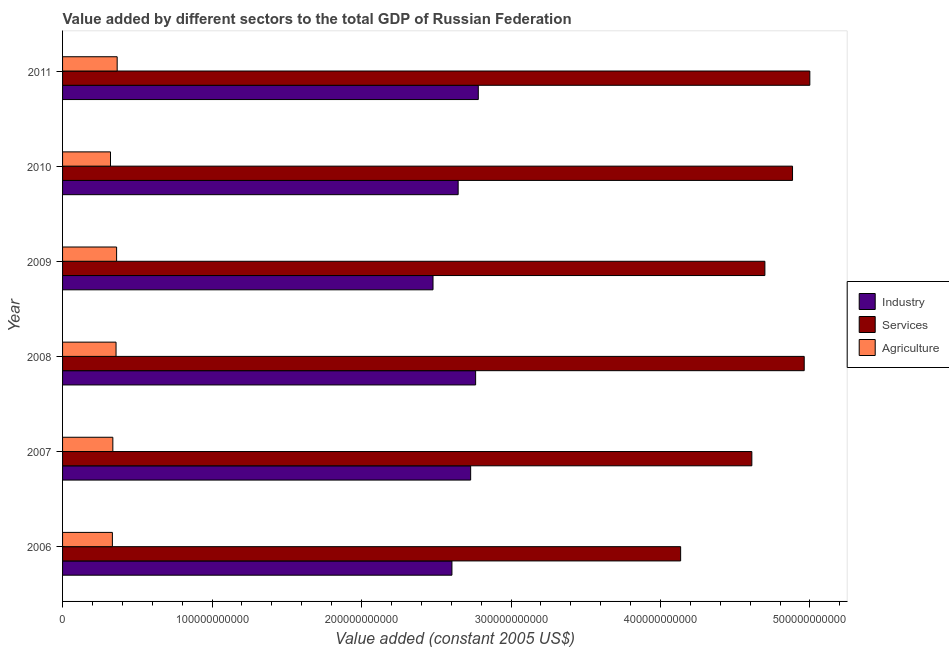How many groups of bars are there?
Provide a succinct answer. 6. Are the number of bars per tick equal to the number of legend labels?
Ensure brevity in your answer.  Yes. Are the number of bars on each tick of the Y-axis equal?
Ensure brevity in your answer.  Yes. How many bars are there on the 4th tick from the top?
Make the answer very short. 3. How many bars are there on the 4th tick from the bottom?
Offer a terse response. 3. What is the value added by services in 2007?
Make the answer very short. 4.61e+11. Across all years, what is the maximum value added by services?
Ensure brevity in your answer.  5.00e+11. Across all years, what is the minimum value added by services?
Your answer should be compact. 4.13e+11. What is the total value added by industrial sector in the graph?
Provide a succinct answer. 1.60e+12. What is the difference between the value added by agricultural sector in 2006 and that in 2007?
Give a very brief answer. -3.06e+08. What is the difference between the value added by agricultural sector in 2010 and the value added by services in 2011?
Provide a succinct answer. -4.68e+11. What is the average value added by services per year?
Ensure brevity in your answer.  4.71e+11. In the year 2010, what is the difference between the value added by industrial sector and value added by agricultural sector?
Your answer should be compact. 2.33e+11. What is the ratio of the value added by services in 2007 to that in 2011?
Provide a succinct answer. 0.92. Is the value added by agricultural sector in 2006 less than that in 2011?
Offer a terse response. Yes. What is the difference between the highest and the second highest value added by agricultural sector?
Your answer should be very brief. 3.86e+08. What is the difference between the highest and the lowest value added by industrial sector?
Offer a terse response. 3.03e+1. In how many years, is the value added by services greater than the average value added by services taken over all years?
Keep it short and to the point. 3. What does the 2nd bar from the top in 2007 represents?
Your response must be concise. Services. What does the 2nd bar from the bottom in 2011 represents?
Offer a terse response. Services. How many bars are there?
Your response must be concise. 18. Are all the bars in the graph horizontal?
Offer a terse response. Yes. How many years are there in the graph?
Offer a terse response. 6. What is the difference between two consecutive major ticks on the X-axis?
Offer a very short reply. 1.00e+11. Does the graph contain grids?
Your response must be concise. No. How many legend labels are there?
Give a very brief answer. 3. How are the legend labels stacked?
Your answer should be compact. Vertical. What is the title of the graph?
Offer a terse response. Value added by different sectors to the total GDP of Russian Federation. Does "Communicable diseases" appear as one of the legend labels in the graph?
Give a very brief answer. No. What is the label or title of the X-axis?
Offer a very short reply. Value added (constant 2005 US$). What is the Value added (constant 2005 US$) in Industry in 2006?
Ensure brevity in your answer.  2.60e+11. What is the Value added (constant 2005 US$) of Services in 2006?
Ensure brevity in your answer.  4.13e+11. What is the Value added (constant 2005 US$) of Agriculture in 2006?
Your answer should be compact. 3.33e+1. What is the Value added (constant 2005 US$) in Industry in 2007?
Your response must be concise. 2.73e+11. What is the Value added (constant 2005 US$) of Services in 2007?
Offer a very short reply. 4.61e+11. What is the Value added (constant 2005 US$) of Agriculture in 2007?
Offer a very short reply. 3.36e+1. What is the Value added (constant 2005 US$) in Industry in 2008?
Ensure brevity in your answer.  2.76e+11. What is the Value added (constant 2005 US$) in Services in 2008?
Your response must be concise. 4.96e+11. What is the Value added (constant 2005 US$) in Agriculture in 2008?
Offer a terse response. 3.58e+1. What is the Value added (constant 2005 US$) of Industry in 2009?
Offer a terse response. 2.48e+11. What is the Value added (constant 2005 US$) of Services in 2009?
Keep it short and to the point. 4.70e+11. What is the Value added (constant 2005 US$) in Agriculture in 2009?
Provide a succinct answer. 3.61e+1. What is the Value added (constant 2005 US$) of Industry in 2010?
Make the answer very short. 2.65e+11. What is the Value added (constant 2005 US$) of Services in 2010?
Your answer should be very brief. 4.88e+11. What is the Value added (constant 2005 US$) in Agriculture in 2010?
Provide a short and direct response. 3.21e+1. What is the Value added (constant 2005 US$) of Industry in 2011?
Your answer should be very brief. 2.78e+11. What is the Value added (constant 2005 US$) of Services in 2011?
Your answer should be very brief. 5.00e+11. What is the Value added (constant 2005 US$) of Agriculture in 2011?
Ensure brevity in your answer.  3.65e+1. Across all years, what is the maximum Value added (constant 2005 US$) of Industry?
Give a very brief answer. 2.78e+11. Across all years, what is the maximum Value added (constant 2005 US$) in Services?
Ensure brevity in your answer.  5.00e+11. Across all years, what is the maximum Value added (constant 2005 US$) in Agriculture?
Keep it short and to the point. 3.65e+1. Across all years, what is the minimum Value added (constant 2005 US$) of Industry?
Your answer should be very brief. 2.48e+11. Across all years, what is the minimum Value added (constant 2005 US$) of Services?
Provide a succinct answer. 4.13e+11. Across all years, what is the minimum Value added (constant 2005 US$) of Agriculture?
Offer a very short reply. 3.21e+1. What is the total Value added (constant 2005 US$) in Industry in the graph?
Make the answer very short. 1.60e+12. What is the total Value added (constant 2005 US$) in Services in the graph?
Keep it short and to the point. 2.83e+12. What is the total Value added (constant 2005 US$) of Agriculture in the graph?
Ensure brevity in your answer.  2.07e+11. What is the difference between the Value added (constant 2005 US$) in Industry in 2006 and that in 2007?
Ensure brevity in your answer.  -1.25e+1. What is the difference between the Value added (constant 2005 US$) in Services in 2006 and that in 2007?
Offer a terse response. -4.76e+1. What is the difference between the Value added (constant 2005 US$) in Agriculture in 2006 and that in 2007?
Your response must be concise. -3.06e+08. What is the difference between the Value added (constant 2005 US$) of Industry in 2006 and that in 2008?
Provide a succinct answer. -1.58e+1. What is the difference between the Value added (constant 2005 US$) of Services in 2006 and that in 2008?
Your answer should be compact. -8.27e+1. What is the difference between the Value added (constant 2005 US$) of Agriculture in 2006 and that in 2008?
Your response must be concise. -2.44e+09. What is the difference between the Value added (constant 2005 US$) of Industry in 2006 and that in 2009?
Your answer should be very brief. 1.27e+1. What is the difference between the Value added (constant 2005 US$) in Services in 2006 and that in 2009?
Offer a very short reply. -5.64e+1. What is the difference between the Value added (constant 2005 US$) of Agriculture in 2006 and that in 2009?
Offer a terse response. -2.82e+09. What is the difference between the Value added (constant 2005 US$) in Industry in 2006 and that in 2010?
Offer a very short reply. -4.16e+09. What is the difference between the Value added (constant 2005 US$) of Services in 2006 and that in 2010?
Keep it short and to the point. -7.49e+1. What is the difference between the Value added (constant 2005 US$) of Agriculture in 2006 and that in 2010?
Ensure brevity in your answer.  1.27e+09. What is the difference between the Value added (constant 2005 US$) of Industry in 2006 and that in 2011?
Give a very brief answer. -1.76e+1. What is the difference between the Value added (constant 2005 US$) of Services in 2006 and that in 2011?
Your answer should be very brief. -8.64e+1. What is the difference between the Value added (constant 2005 US$) of Agriculture in 2006 and that in 2011?
Offer a very short reply. -3.21e+09. What is the difference between the Value added (constant 2005 US$) in Industry in 2007 and that in 2008?
Keep it short and to the point. -3.32e+09. What is the difference between the Value added (constant 2005 US$) in Services in 2007 and that in 2008?
Offer a very short reply. -3.50e+1. What is the difference between the Value added (constant 2005 US$) of Agriculture in 2007 and that in 2008?
Offer a very short reply. -2.14e+09. What is the difference between the Value added (constant 2005 US$) of Industry in 2007 and that in 2009?
Your answer should be very brief. 2.52e+1. What is the difference between the Value added (constant 2005 US$) of Services in 2007 and that in 2009?
Your answer should be compact. -8.73e+09. What is the difference between the Value added (constant 2005 US$) of Agriculture in 2007 and that in 2009?
Keep it short and to the point. -2.51e+09. What is the difference between the Value added (constant 2005 US$) of Industry in 2007 and that in 2010?
Your response must be concise. 8.37e+09. What is the difference between the Value added (constant 2005 US$) of Services in 2007 and that in 2010?
Keep it short and to the point. -2.72e+1. What is the difference between the Value added (constant 2005 US$) of Agriculture in 2007 and that in 2010?
Your answer should be compact. 1.57e+09. What is the difference between the Value added (constant 2005 US$) in Industry in 2007 and that in 2011?
Your response must be concise. -5.12e+09. What is the difference between the Value added (constant 2005 US$) in Services in 2007 and that in 2011?
Your answer should be very brief. -3.88e+1. What is the difference between the Value added (constant 2005 US$) of Agriculture in 2007 and that in 2011?
Ensure brevity in your answer.  -2.90e+09. What is the difference between the Value added (constant 2005 US$) of Industry in 2008 and that in 2009?
Make the answer very short. 2.85e+1. What is the difference between the Value added (constant 2005 US$) of Services in 2008 and that in 2009?
Offer a very short reply. 2.63e+1. What is the difference between the Value added (constant 2005 US$) of Agriculture in 2008 and that in 2009?
Provide a succinct answer. -3.77e+08. What is the difference between the Value added (constant 2005 US$) in Industry in 2008 and that in 2010?
Keep it short and to the point. 1.17e+1. What is the difference between the Value added (constant 2005 US$) in Services in 2008 and that in 2010?
Provide a succinct answer. 7.82e+09. What is the difference between the Value added (constant 2005 US$) of Agriculture in 2008 and that in 2010?
Ensure brevity in your answer.  3.71e+09. What is the difference between the Value added (constant 2005 US$) of Industry in 2008 and that in 2011?
Offer a terse response. -1.80e+09. What is the difference between the Value added (constant 2005 US$) of Services in 2008 and that in 2011?
Your answer should be very brief. -3.76e+09. What is the difference between the Value added (constant 2005 US$) in Agriculture in 2008 and that in 2011?
Your answer should be compact. -7.63e+08. What is the difference between the Value added (constant 2005 US$) of Industry in 2009 and that in 2010?
Ensure brevity in your answer.  -1.68e+1. What is the difference between the Value added (constant 2005 US$) in Services in 2009 and that in 2010?
Ensure brevity in your answer.  -1.85e+1. What is the difference between the Value added (constant 2005 US$) of Agriculture in 2009 and that in 2010?
Give a very brief answer. 4.09e+09. What is the difference between the Value added (constant 2005 US$) in Industry in 2009 and that in 2011?
Your response must be concise. -3.03e+1. What is the difference between the Value added (constant 2005 US$) of Services in 2009 and that in 2011?
Provide a short and direct response. -3.01e+1. What is the difference between the Value added (constant 2005 US$) in Agriculture in 2009 and that in 2011?
Make the answer very short. -3.86e+08. What is the difference between the Value added (constant 2005 US$) of Industry in 2010 and that in 2011?
Ensure brevity in your answer.  -1.35e+1. What is the difference between the Value added (constant 2005 US$) of Services in 2010 and that in 2011?
Ensure brevity in your answer.  -1.16e+1. What is the difference between the Value added (constant 2005 US$) of Agriculture in 2010 and that in 2011?
Provide a succinct answer. -4.47e+09. What is the difference between the Value added (constant 2005 US$) of Industry in 2006 and the Value added (constant 2005 US$) of Services in 2007?
Make the answer very short. -2.01e+11. What is the difference between the Value added (constant 2005 US$) of Industry in 2006 and the Value added (constant 2005 US$) of Agriculture in 2007?
Offer a terse response. 2.27e+11. What is the difference between the Value added (constant 2005 US$) of Services in 2006 and the Value added (constant 2005 US$) of Agriculture in 2007?
Your response must be concise. 3.80e+11. What is the difference between the Value added (constant 2005 US$) of Industry in 2006 and the Value added (constant 2005 US$) of Services in 2008?
Offer a very short reply. -2.36e+11. What is the difference between the Value added (constant 2005 US$) of Industry in 2006 and the Value added (constant 2005 US$) of Agriculture in 2008?
Your answer should be very brief. 2.25e+11. What is the difference between the Value added (constant 2005 US$) of Services in 2006 and the Value added (constant 2005 US$) of Agriculture in 2008?
Your answer should be very brief. 3.78e+11. What is the difference between the Value added (constant 2005 US$) in Industry in 2006 and the Value added (constant 2005 US$) in Services in 2009?
Your response must be concise. -2.09e+11. What is the difference between the Value added (constant 2005 US$) in Industry in 2006 and the Value added (constant 2005 US$) in Agriculture in 2009?
Provide a succinct answer. 2.24e+11. What is the difference between the Value added (constant 2005 US$) in Services in 2006 and the Value added (constant 2005 US$) in Agriculture in 2009?
Offer a terse response. 3.77e+11. What is the difference between the Value added (constant 2005 US$) of Industry in 2006 and the Value added (constant 2005 US$) of Services in 2010?
Provide a short and direct response. -2.28e+11. What is the difference between the Value added (constant 2005 US$) in Industry in 2006 and the Value added (constant 2005 US$) in Agriculture in 2010?
Your answer should be compact. 2.28e+11. What is the difference between the Value added (constant 2005 US$) of Services in 2006 and the Value added (constant 2005 US$) of Agriculture in 2010?
Your answer should be compact. 3.81e+11. What is the difference between the Value added (constant 2005 US$) of Industry in 2006 and the Value added (constant 2005 US$) of Services in 2011?
Ensure brevity in your answer.  -2.39e+11. What is the difference between the Value added (constant 2005 US$) of Industry in 2006 and the Value added (constant 2005 US$) of Agriculture in 2011?
Offer a very short reply. 2.24e+11. What is the difference between the Value added (constant 2005 US$) in Services in 2006 and the Value added (constant 2005 US$) in Agriculture in 2011?
Your answer should be compact. 3.77e+11. What is the difference between the Value added (constant 2005 US$) in Industry in 2007 and the Value added (constant 2005 US$) in Services in 2008?
Keep it short and to the point. -2.23e+11. What is the difference between the Value added (constant 2005 US$) in Industry in 2007 and the Value added (constant 2005 US$) in Agriculture in 2008?
Make the answer very short. 2.37e+11. What is the difference between the Value added (constant 2005 US$) of Services in 2007 and the Value added (constant 2005 US$) of Agriculture in 2008?
Your answer should be very brief. 4.25e+11. What is the difference between the Value added (constant 2005 US$) in Industry in 2007 and the Value added (constant 2005 US$) in Services in 2009?
Provide a succinct answer. -1.97e+11. What is the difference between the Value added (constant 2005 US$) in Industry in 2007 and the Value added (constant 2005 US$) in Agriculture in 2009?
Provide a succinct answer. 2.37e+11. What is the difference between the Value added (constant 2005 US$) of Services in 2007 and the Value added (constant 2005 US$) of Agriculture in 2009?
Offer a very short reply. 4.25e+11. What is the difference between the Value added (constant 2005 US$) of Industry in 2007 and the Value added (constant 2005 US$) of Services in 2010?
Keep it short and to the point. -2.15e+11. What is the difference between the Value added (constant 2005 US$) in Industry in 2007 and the Value added (constant 2005 US$) in Agriculture in 2010?
Offer a terse response. 2.41e+11. What is the difference between the Value added (constant 2005 US$) of Services in 2007 and the Value added (constant 2005 US$) of Agriculture in 2010?
Offer a terse response. 4.29e+11. What is the difference between the Value added (constant 2005 US$) of Industry in 2007 and the Value added (constant 2005 US$) of Services in 2011?
Offer a terse response. -2.27e+11. What is the difference between the Value added (constant 2005 US$) in Industry in 2007 and the Value added (constant 2005 US$) in Agriculture in 2011?
Your response must be concise. 2.36e+11. What is the difference between the Value added (constant 2005 US$) in Services in 2007 and the Value added (constant 2005 US$) in Agriculture in 2011?
Offer a very short reply. 4.25e+11. What is the difference between the Value added (constant 2005 US$) in Industry in 2008 and the Value added (constant 2005 US$) in Services in 2009?
Give a very brief answer. -1.94e+11. What is the difference between the Value added (constant 2005 US$) of Industry in 2008 and the Value added (constant 2005 US$) of Agriculture in 2009?
Offer a very short reply. 2.40e+11. What is the difference between the Value added (constant 2005 US$) of Services in 2008 and the Value added (constant 2005 US$) of Agriculture in 2009?
Offer a terse response. 4.60e+11. What is the difference between the Value added (constant 2005 US$) of Industry in 2008 and the Value added (constant 2005 US$) of Services in 2010?
Your answer should be compact. -2.12e+11. What is the difference between the Value added (constant 2005 US$) in Industry in 2008 and the Value added (constant 2005 US$) in Agriculture in 2010?
Offer a very short reply. 2.44e+11. What is the difference between the Value added (constant 2005 US$) in Services in 2008 and the Value added (constant 2005 US$) in Agriculture in 2010?
Provide a short and direct response. 4.64e+11. What is the difference between the Value added (constant 2005 US$) of Industry in 2008 and the Value added (constant 2005 US$) of Services in 2011?
Your answer should be very brief. -2.24e+11. What is the difference between the Value added (constant 2005 US$) in Industry in 2008 and the Value added (constant 2005 US$) in Agriculture in 2011?
Provide a short and direct response. 2.40e+11. What is the difference between the Value added (constant 2005 US$) in Services in 2008 and the Value added (constant 2005 US$) in Agriculture in 2011?
Your answer should be compact. 4.60e+11. What is the difference between the Value added (constant 2005 US$) in Industry in 2009 and the Value added (constant 2005 US$) in Services in 2010?
Give a very brief answer. -2.41e+11. What is the difference between the Value added (constant 2005 US$) of Industry in 2009 and the Value added (constant 2005 US$) of Agriculture in 2010?
Your response must be concise. 2.16e+11. What is the difference between the Value added (constant 2005 US$) in Services in 2009 and the Value added (constant 2005 US$) in Agriculture in 2010?
Provide a short and direct response. 4.38e+11. What is the difference between the Value added (constant 2005 US$) in Industry in 2009 and the Value added (constant 2005 US$) in Services in 2011?
Keep it short and to the point. -2.52e+11. What is the difference between the Value added (constant 2005 US$) in Industry in 2009 and the Value added (constant 2005 US$) in Agriculture in 2011?
Make the answer very short. 2.11e+11. What is the difference between the Value added (constant 2005 US$) of Services in 2009 and the Value added (constant 2005 US$) of Agriculture in 2011?
Your answer should be compact. 4.33e+11. What is the difference between the Value added (constant 2005 US$) in Industry in 2010 and the Value added (constant 2005 US$) in Services in 2011?
Provide a short and direct response. -2.35e+11. What is the difference between the Value added (constant 2005 US$) in Industry in 2010 and the Value added (constant 2005 US$) in Agriculture in 2011?
Offer a terse response. 2.28e+11. What is the difference between the Value added (constant 2005 US$) of Services in 2010 and the Value added (constant 2005 US$) of Agriculture in 2011?
Make the answer very short. 4.52e+11. What is the average Value added (constant 2005 US$) in Industry per year?
Ensure brevity in your answer.  2.67e+11. What is the average Value added (constant 2005 US$) in Services per year?
Provide a short and direct response. 4.71e+11. What is the average Value added (constant 2005 US$) in Agriculture per year?
Provide a short and direct response. 3.46e+1. In the year 2006, what is the difference between the Value added (constant 2005 US$) of Industry and Value added (constant 2005 US$) of Services?
Offer a terse response. -1.53e+11. In the year 2006, what is the difference between the Value added (constant 2005 US$) of Industry and Value added (constant 2005 US$) of Agriculture?
Offer a very short reply. 2.27e+11. In the year 2006, what is the difference between the Value added (constant 2005 US$) of Services and Value added (constant 2005 US$) of Agriculture?
Keep it short and to the point. 3.80e+11. In the year 2007, what is the difference between the Value added (constant 2005 US$) in Industry and Value added (constant 2005 US$) in Services?
Make the answer very short. -1.88e+11. In the year 2007, what is the difference between the Value added (constant 2005 US$) of Industry and Value added (constant 2005 US$) of Agriculture?
Provide a succinct answer. 2.39e+11. In the year 2007, what is the difference between the Value added (constant 2005 US$) in Services and Value added (constant 2005 US$) in Agriculture?
Offer a terse response. 4.27e+11. In the year 2008, what is the difference between the Value added (constant 2005 US$) in Industry and Value added (constant 2005 US$) in Services?
Make the answer very short. -2.20e+11. In the year 2008, what is the difference between the Value added (constant 2005 US$) of Industry and Value added (constant 2005 US$) of Agriculture?
Your answer should be very brief. 2.41e+11. In the year 2008, what is the difference between the Value added (constant 2005 US$) in Services and Value added (constant 2005 US$) in Agriculture?
Keep it short and to the point. 4.60e+11. In the year 2009, what is the difference between the Value added (constant 2005 US$) of Industry and Value added (constant 2005 US$) of Services?
Offer a very short reply. -2.22e+11. In the year 2009, what is the difference between the Value added (constant 2005 US$) of Industry and Value added (constant 2005 US$) of Agriculture?
Offer a terse response. 2.12e+11. In the year 2009, what is the difference between the Value added (constant 2005 US$) of Services and Value added (constant 2005 US$) of Agriculture?
Make the answer very short. 4.34e+11. In the year 2010, what is the difference between the Value added (constant 2005 US$) in Industry and Value added (constant 2005 US$) in Services?
Provide a short and direct response. -2.24e+11. In the year 2010, what is the difference between the Value added (constant 2005 US$) in Industry and Value added (constant 2005 US$) in Agriculture?
Make the answer very short. 2.33e+11. In the year 2010, what is the difference between the Value added (constant 2005 US$) of Services and Value added (constant 2005 US$) of Agriculture?
Your answer should be very brief. 4.56e+11. In the year 2011, what is the difference between the Value added (constant 2005 US$) in Industry and Value added (constant 2005 US$) in Services?
Your answer should be very brief. -2.22e+11. In the year 2011, what is the difference between the Value added (constant 2005 US$) in Industry and Value added (constant 2005 US$) in Agriculture?
Your response must be concise. 2.42e+11. In the year 2011, what is the difference between the Value added (constant 2005 US$) of Services and Value added (constant 2005 US$) of Agriculture?
Ensure brevity in your answer.  4.63e+11. What is the ratio of the Value added (constant 2005 US$) in Industry in 2006 to that in 2007?
Make the answer very short. 0.95. What is the ratio of the Value added (constant 2005 US$) of Services in 2006 to that in 2007?
Offer a terse response. 0.9. What is the ratio of the Value added (constant 2005 US$) in Agriculture in 2006 to that in 2007?
Make the answer very short. 0.99. What is the ratio of the Value added (constant 2005 US$) of Industry in 2006 to that in 2008?
Your answer should be compact. 0.94. What is the ratio of the Value added (constant 2005 US$) of Services in 2006 to that in 2008?
Give a very brief answer. 0.83. What is the ratio of the Value added (constant 2005 US$) in Agriculture in 2006 to that in 2008?
Provide a short and direct response. 0.93. What is the ratio of the Value added (constant 2005 US$) in Industry in 2006 to that in 2009?
Offer a terse response. 1.05. What is the ratio of the Value added (constant 2005 US$) in Services in 2006 to that in 2009?
Your response must be concise. 0.88. What is the ratio of the Value added (constant 2005 US$) of Agriculture in 2006 to that in 2009?
Ensure brevity in your answer.  0.92. What is the ratio of the Value added (constant 2005 US$) in Industry in 2006 to that in 2010?
Your answer should be very brief. 0.98. What is the ratio of the Value added (constant 2005 US$) in Services in 2006 to that in 2010?
Your response must be concise. 0.85. What is the ratio of the Value added (constant 2005 US$) in Agriculture in 2006 to that in 2010?
Offer a very short reply. 1.04. What is the ratio of the Value added (constant 2005 US$) of Industry in 2006 to that in 2011?
Ensure brevity in your answer.  0.94. What is the ratio of the Value added (constant 2005 US$) in Services in 2006 to that in 2011?
Your response must be concise. 0.83. What is the ratio of the Value added (constant 2005 US$) of Agriculture in 2006 to that in 2011?
Provide a succinct answer. 0.91. What is the ratio of the Value added (constant 2005 US$) in Services in 2007 to that in 2008?
Make the answer very short. 0.93. What is the ratio of the Value added (constant 2005 US$) in Agriculture in 2007 to that in 2008?
Your answer should be very brief. 0.94. What is the ratio of the Value added (constant 2005 US$) in Industry in 2007 to that in 2009?
Your response must be concise. 1.1. What is the ratio of the Value added (constant 2005 US$) of Services in 2007 to that in 2009?
Provide a short and direct response. 0.98. What is the ratio of the Value added (constant 2005 US$) in Agriculture in 2007 to that in 2009?
Your answer should be very brief. 0.93. What is the ratio of the Value added (constant 2005 US$) in Industry in 2007 to that in 2010?
Provide a succinct answer. 1.03. What is the ratio of the Value added (constant 2005 US$) of Services in 2007 to that in 2010?
Your answer should be very brief. 0.94. What is the ratio of the Value added (constant 2005 US$) in Agriculture in 2007 to that in 2010?
Offer a terse response. 1.05. What is the ratio of the Value added (constant 2005 US$) of Industry in 2007 to that in 2011?
Provide a succinct answer. 0.98. What is the ratio of the Value added (constant 2005 US$) of Services in 2007 to that in 2011?
Offer a very short reply. 0.92. What is the ratio of the Value added (constant 2005 US$) of Agriculture in 2007 to that in 2011?
Provide a succinct answer. 0.92. What is the ratio of the Value added (constant 2005 US$) in Industry in 2008 to that in 2009?
Provide a succinct answer. 1.11. What is the ratio of the Value added (constant 2005 US$) in Services in 2008 to that in 2009?
Keep it short and to the point. 1.06. What is the ratio of the Value added (constant 2005 US$) of Industry in 2008 to that in 2010?
Your answer should be very brief. 1.04. What is the ratio of the Value added (constant 2005 US$) of Services in 2008 to that in 2010?
Make the answer very short. 1.02. What is the ratio of the Value added (constant 2005 US$) of Agriculture in 2008 to that in 2010?
Provide a succinct answer. 1.12. What is the ratio of the Value added (constant 2005 US$) in Agriculture in 2008 to that in 2011?
Ensure brevity in your answer.  0.98. What is the ratio of the Value added (constant 2005 US$) of Industry in 2009 to that in 2010?
Offer a very short reply. 0.94. What is the ratio of the Value added (constant 2005 US$) of Services in 2009 to that in 2010?
Provide a succinct answer. 0.96. What is the ratio of the Value added (constant 2005 US$) of Agriculture in 2009 to that in 2010?
Provide a short and direct response. 1.13. What is the ratio of the Value added (constant 2005 US$) of Industry in 2009 to that in 2011?
Your response must be concise. 0.89. What is the ratio of the Value added (constant 2005 US$) of Services in 2009 to that in 2011?
Your answer should be compact. 0.94. What is the ratio of the Value added (constant 2005 US$) in Industry in 2010 to that in 2011?
Your response must be concise. 0.95. What is the ratio of the Value added (constant 2005 US$) in Services in 2010 to that in 2011?
Ensure brevity in your answer.  0.98. What is the ratio of the Value added (constant 2005 US$) in Agriculture in 2010 to that in 2011?
Your answer should be very brief. 0.88. What is the difference between the highest and the second highest Value added (constant 2005 US$) in Industry?
Your answer should be compact. 1.80e+09. What is the difference between the highest and the second highest Value added (constant 2005 US$) of Services?
Offer a terse response. 3.76e+09. What is the difference between the highest and the second highest Value added (constant 2005 US$) in Agriculture?
Offer a very short reply. 3.86e+08. What is the difference between the highest and the lowest Value added (constant 2005 US$) in Industry?
Your response must be concise. 3.03e+1. What is the difference between the highest and the lowest Value added (constant 2005 US$) of Services?
Offer a terse response. 8.64e+1. What is the difference between the highest and the lowest Value added (constant 2005 US$) in Agriculture?
Your response must be concise. 4.47e+09. 